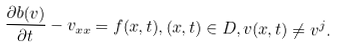<formula> <loc_0><loc_0><loc_500><loc_500>\frac { \partial b ( v ) } { \partial t } - v _ { x x } = f ( x , t ) , ( x , t ) \in D , v ( x , t ) \neq v ^ { j } .</formula> 